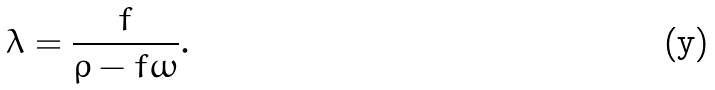<formula> <loc_0><loc_0><loc_500><loc_500>\lambda = \frac { f } { \rho - f \omega } .</formula> 